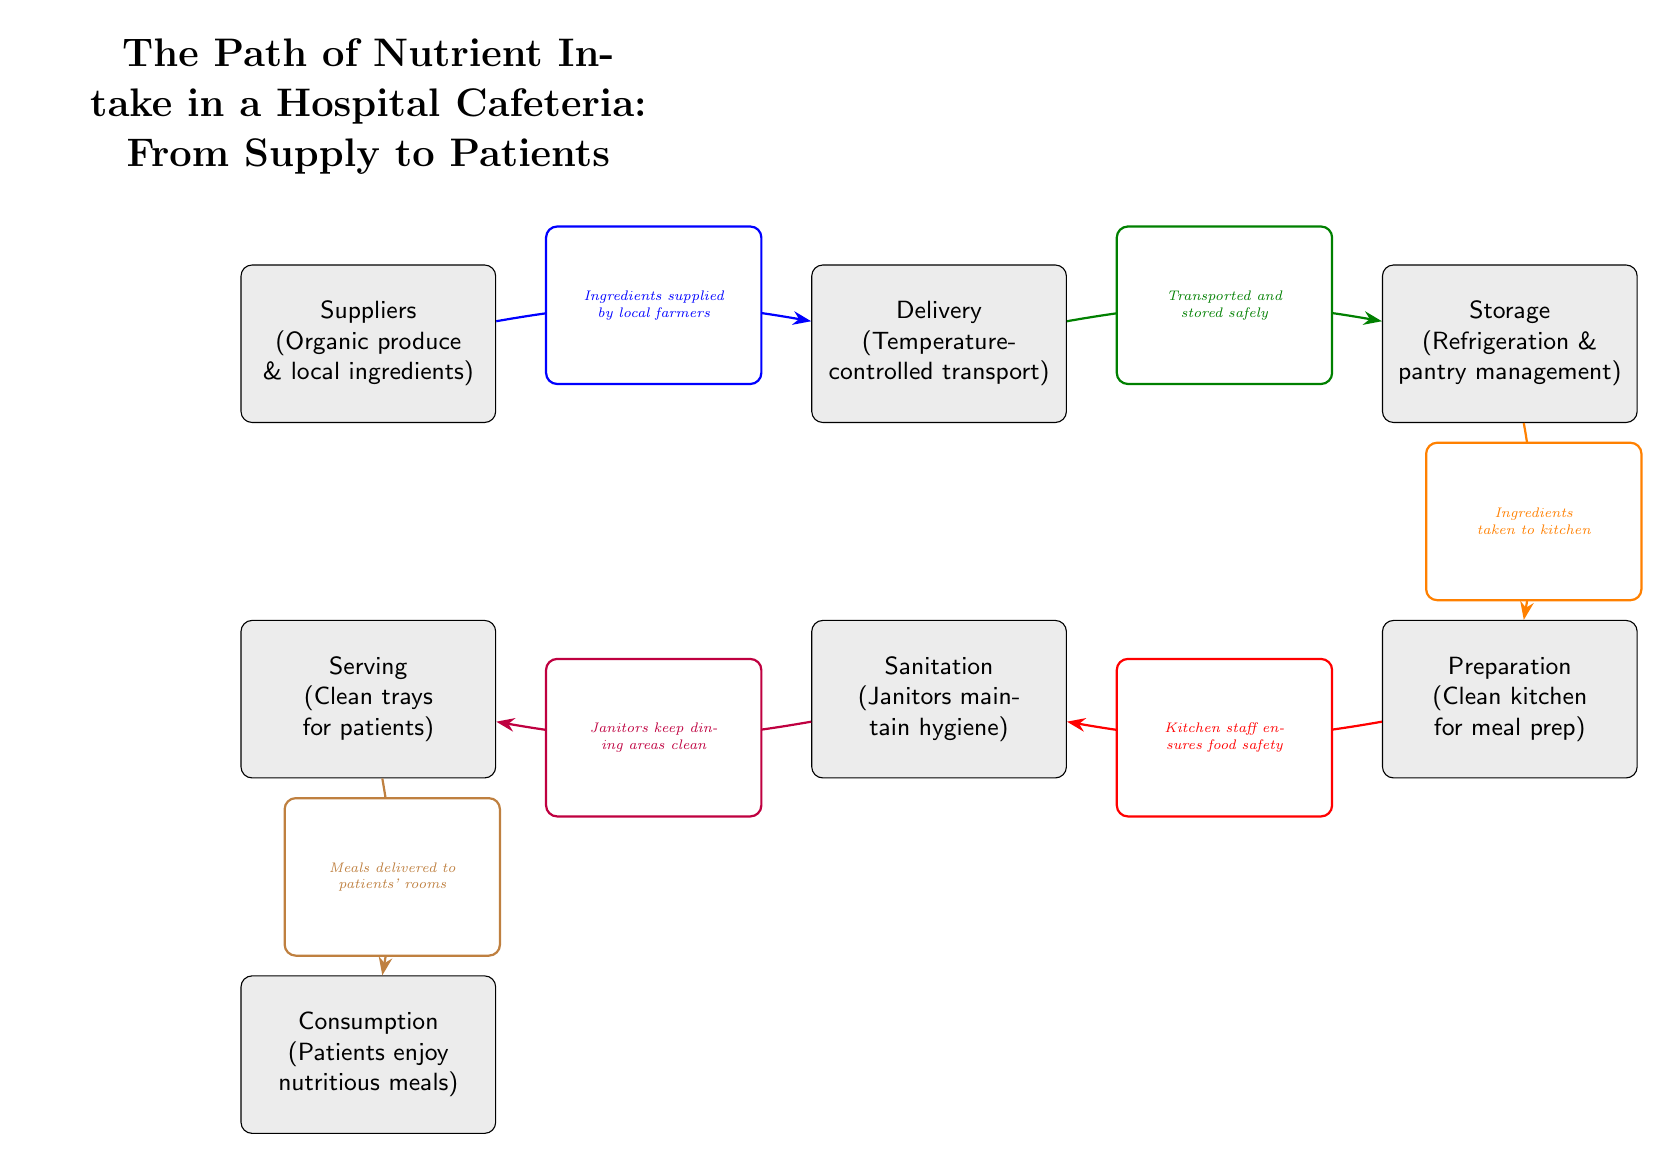What is the first node in the food chain? The first node is "Suppliers (Organic produce & local ingredients)" which represents where the ingredients originate from.
Answer: Suppliers (Organic produce & local ingredients) How many nodes are present in the diagram? To count the nodes, we can identify each labeled box, which totals to six.
Answer: 6 What is the final node that represents patient experience? The final node is "Consumption (Patients enjoy nutritious meals)", which signifies the end of the nutrient path where patients receive the meals.
Answer: Consumption (Patients enjoy nutritious meals) Which node is directly before "Preparation"? The node directly before "Preparation" is "Storage (Refrigeration & pantry management)", as it precedes the kitchen preparation process.
Answer: Storage (Refrigeration & pantry management) What role does the "Sanitation" node play in the food chain? The "Sanitation" node emphasizes the importance of cleanliness, highlighting that janitors maintain hygiene throughout the process leading to food preparation and serving.
Answer: Janitors maintain hygiene What type of transport is used to move ingredients from suppliers to storage? The ingredients are transported using "Temperature-controlled transport," ensuring food safety until they are stored.
Answer: Temperature-controlled transport How does the kitchen staff ensure food safety? The kitchen staff ensures food safety through the "Preparation" stage which is linked to the "Sanitation" node, emphasizing that the foods are handled in a clean environment before serving.
Answer: Kitchen staff ensures food safety Which node indicates the method of delivering meals to patients? The method of delivering meals to patients is indicated in the "Serving (Clean trays for patients)" node, reflecting the importance of using clean utensils for patient service.
Answer: Clean trays for patients What is the flow from "Serving" to "Consumption"? The flow from "Serving" to "Consumption" involves the delivery of meals to patients' rooms, ensuring they receive their meals directly after service.
Answer: Meals delivered to patients' rooms 